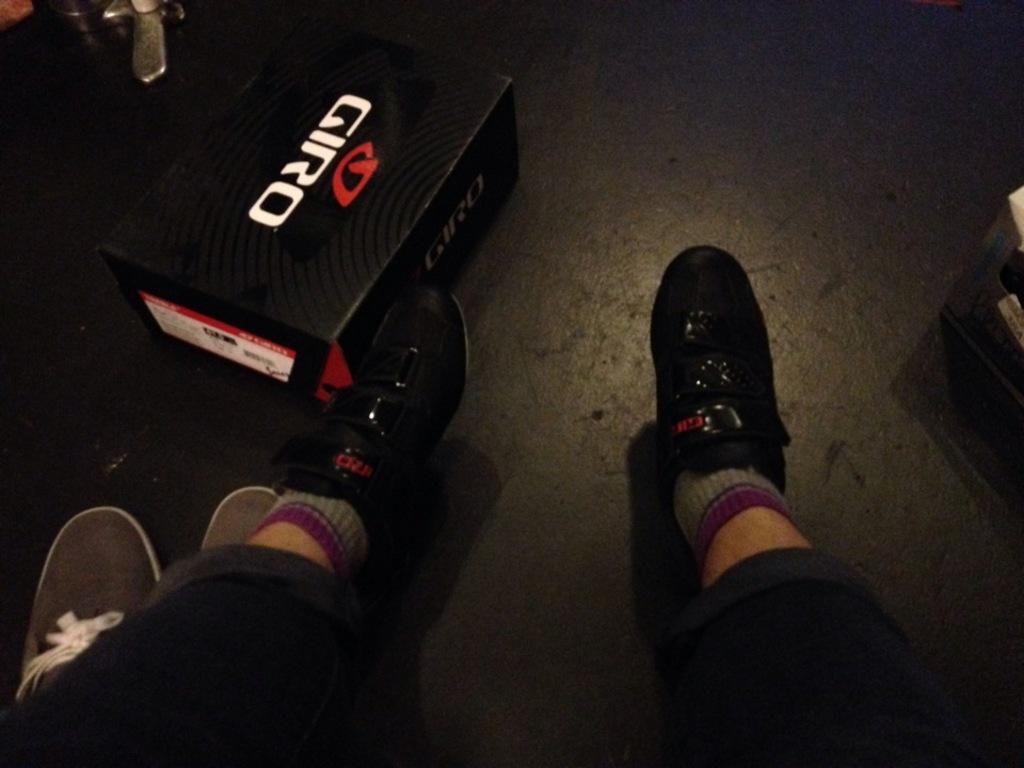What body parts are visible in the image? There are person's legs visible in the image. What object can be seen on the floor in the image? There is a cardboard carton on the floor in the image. What country is the church located in, as seen in the image? There is no church present in the image, so it is not possible to determine the country. 